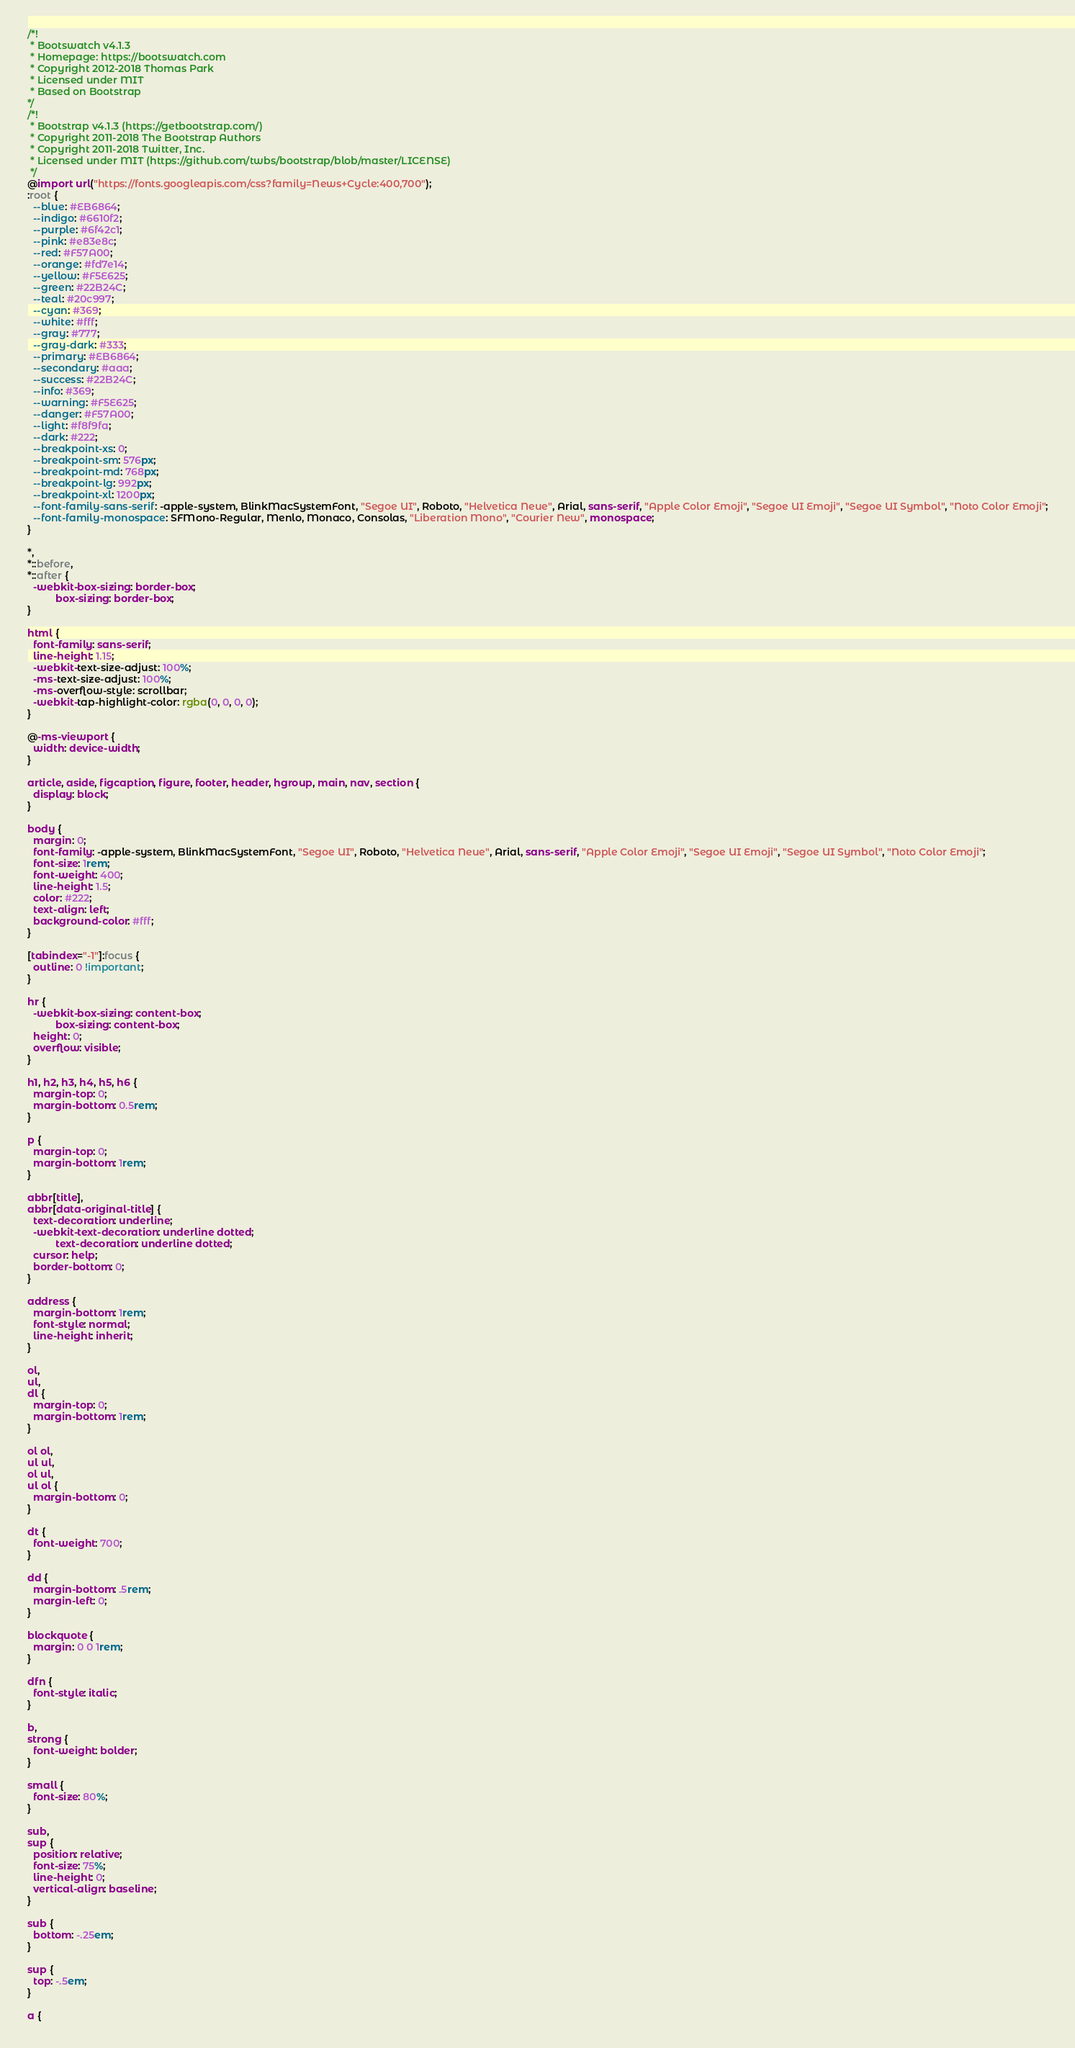Convert code to text. <code><loc_0><loc_0><loc_500><loc_500><_CSS_>/*!
 * Bootswatch v4.1.3
 * Homepage: https://bootswatch.com
 * Copyright 2012-2018 Thomas Park
 * Licensed under MIT
 * Based on Bootstrap
*/
/*!
 * Bootstrap v4.1.3 (https://getbootstrap.com/)
 * Copyright 2011-2018 The Bootstrap Authors
 * Copyright 2011-2018 Twitter, Inc.
 * Licensed under MIT (https://github.com/twbs/bootstrap/blob/master/LICENSE)
 */
@import url("https://fonts.googleapis.com/css?family=News+Cycle:400,700");
:root {
  --blue: #EB6864;
  --indigo: #6610f2;
  --purple: #6f42c1;
  --pink: #e83e8c;
  --red: #F57A00;
  --orange: #fd7e14;
  --yellow: #F5E625;
  --green: #22B24C;
  --teal: #20c997;
  --cyan: #369;
  --white: #fff;
  --gray: #777;
  --gray-dark: #333;
  --primary: #EB6864;
  --secondary: #aaa;
  --success: #22B24C;
  --info: #369;
  --warning: #F5E625;
  --danger: #F57A00;
  --light: #f8f9fa;
  --dark: #222;
  --breakpoint-xs: 0;
  --breakpoint-sm: 576px;
  --breakpoint-md: 768px;
  --breakpoint-lg: 992px;
  --breakpoint-xl: 1200px;
  --font-family-sans-serif: -apple-system, BlinkMacSystemFont, "Segoe UI", Roboto, "Helvetica Neue", Arial, sans-serif, "Apple Color Emoji", "Segoe UI Emoji", "Segoe UI Symbol", "Noto Color Emoji";
  --font-family-monospace: SFMono-Regular, Menlo, Monaco, Consolas, "Liberation Mono", "Courier New", monospace;
}

*,
*::before,
*::after {
  -webkit-box-sizing: border-box;
          box-sizing: border-box;
}

html {
  font-family: sans-serif;
  line-height: 1.15;
  -webkit-text-size-adjust: 100%;
  -ms-text-size-adjust: 100%;
  -ms-overflow-style: scrollbar;
  -webkit-tap-highlight-color: rgba(0, 0, 0, 0);
}

@-ms-viewport {
  width: device-width;
}

article, aside, figcaption, figure, footer, header, hgroup, main, nav, section {
  display: block;
}

body {
  margin: 0;
  font-family: -apple-system, BlinkMacSystemFont, "Segoe UI", Roboto, "Helvetica Neue", Arial, sans-serif, "Apple Color Emoji", "Segoe UI Emoji", "Segoe UI Symbol", "Noto Color Emoji";
  font-size: 1rem;
  font-weight: 400;
  line-height: 1.5;
  color: #222;
  text-align: left;
  background-color: #fff;
}

[tabindex="-1"]:focus {
  outline: 0 !important;
}

hr {
  -webkit-box-sizing: content-box;
          box-sizing: content-box;
  height: 0;
  overflow: visible;
}

h1, h2, h3, h4, h5, h6 {
  margin-top: 0;
  margin-bottom: 0.5rem;
}

p {
  margin-top: 0;
  margin-bottom: 1rem;
}

abbr[title],
abbr[data-original-title] {
  text-decoration: underline;
  -webkit-text-decoration: underline dotted;
          text-decoration: underline dotted;
  cursor: help;
  border-bottom: 0;
}

address {
  margin-bottom: 1rem;
  font-style: normal;
  line-height: inherit;
}

ol,
ul,
dl {
  margin-top: 0;
  margin-bottom: 1rem;
}

ol ol,
ul ul,
ol ul,
ul ol {
  margin-bottom: 0;
}

dt {
  font-weight: 700;
}

dd {
  margin-bottom: .5rem;
  margin-left: 0;
}

blockquote {
  margin: 0 0 1rem;
}

dfn {
  font-style: italic;
}

b,
strong {
  font-weight: bolder;
}

small {
  font-size: 80%;
}

sub,
sup {
  position: relative;
  font-size: 75%;
  line-height: 0;
  vertical-align: baseline;
}

sub {
  bottom: -.25em;
}

sup {
  top: -.5em;
}

a {</code> 